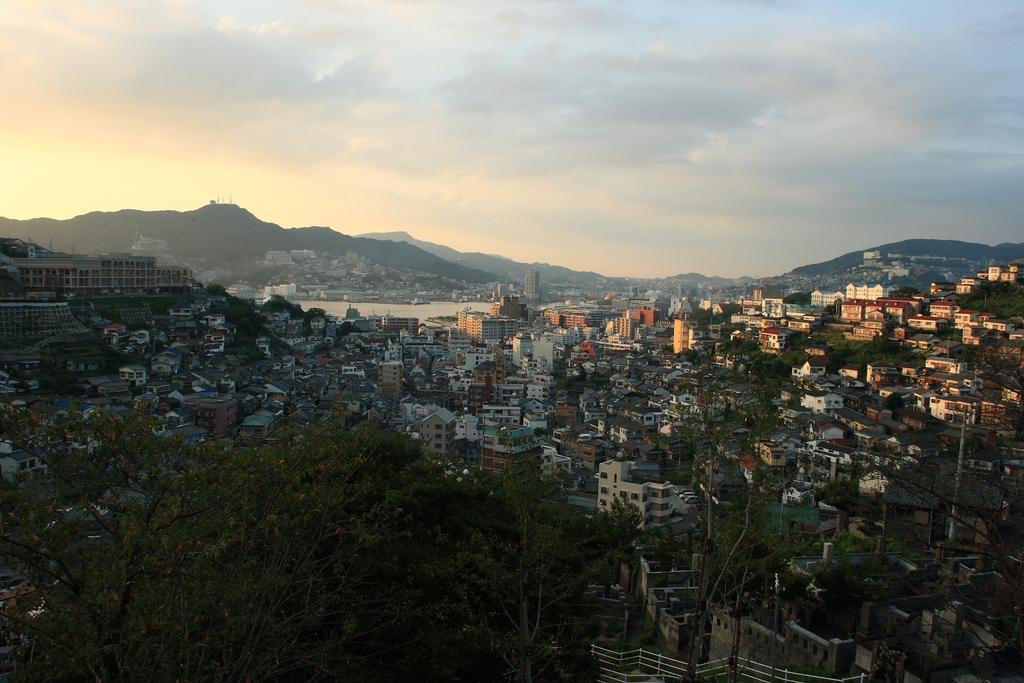What type of view is depicted in the image? The image is an aerial view. What can be seen in the image from this perspective? There are many buildings and trees visible in the image. What is visible in the background of the image? There are hills and the sky visible in the background of the image. What type of humor is being displayed by the minister in the image? There is no minister present in the image, so it is not possible to determine if any humor is being displayed. 